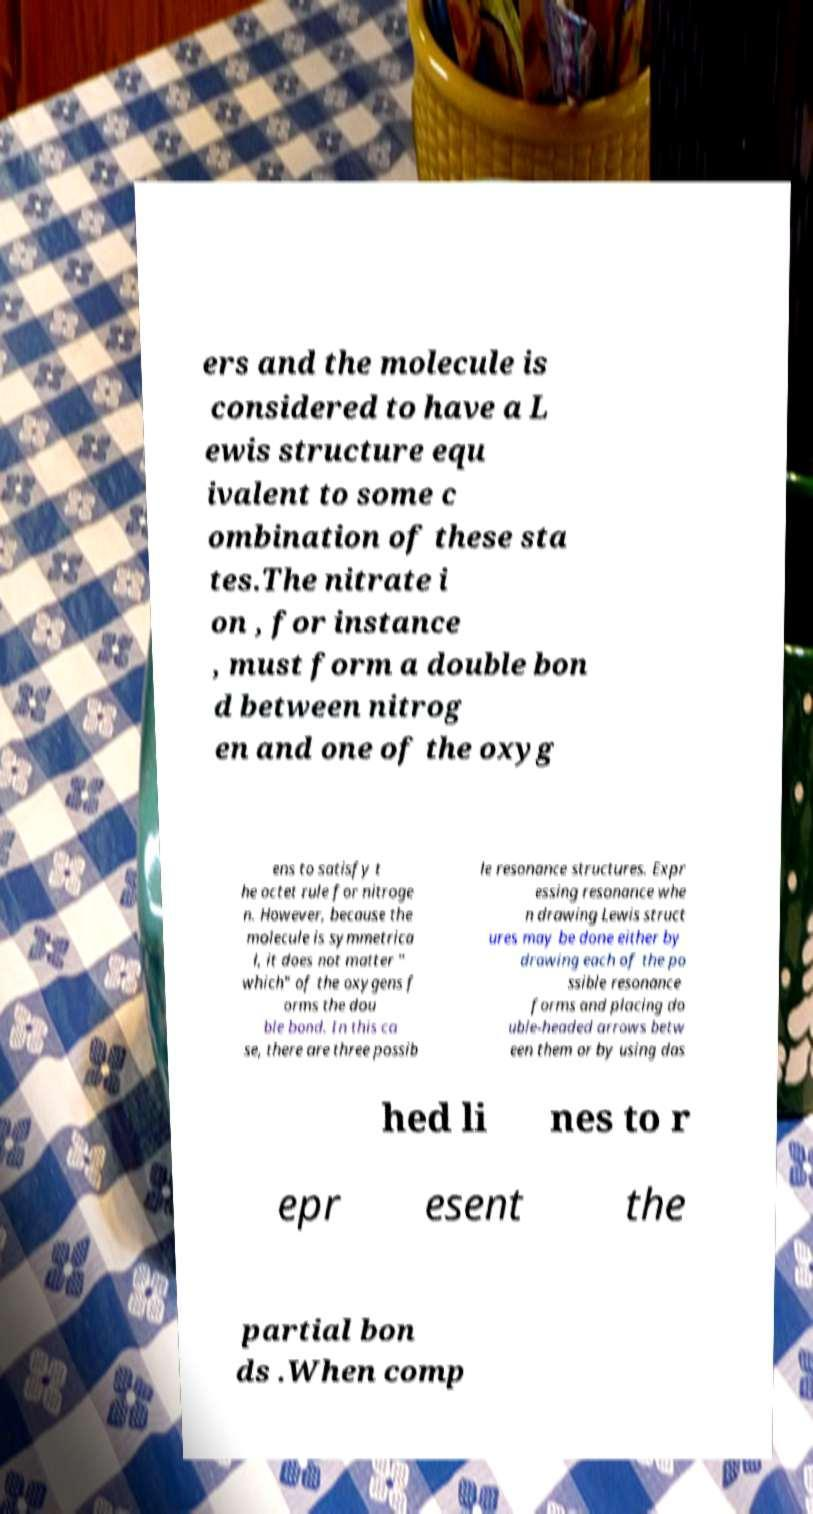For documentation purposes, I need the text within this image transcribed. Could you provide that? ers and the molecule is considered to have a L ewis structure equ ivalent to some c ombination of these sta tes.The nitrate i on , for instance , must form a double bon d between nitrog en and one of the oxyg ens to satisfy t he octet rule for nitroge n. However, because the molecule is symmetrica l, it does not matter " which" of the oxygens f orms the dou ble bond. In this ca se, there are three possib le resonance structures. Expr essing resonance whe n drawing Lewis struct ures may be done either by drawing each of the po ssible resonance forms and placing do uble-headed arrows betw een them or by using das hed li nes to r epr esent the partial bon ds .When comp 